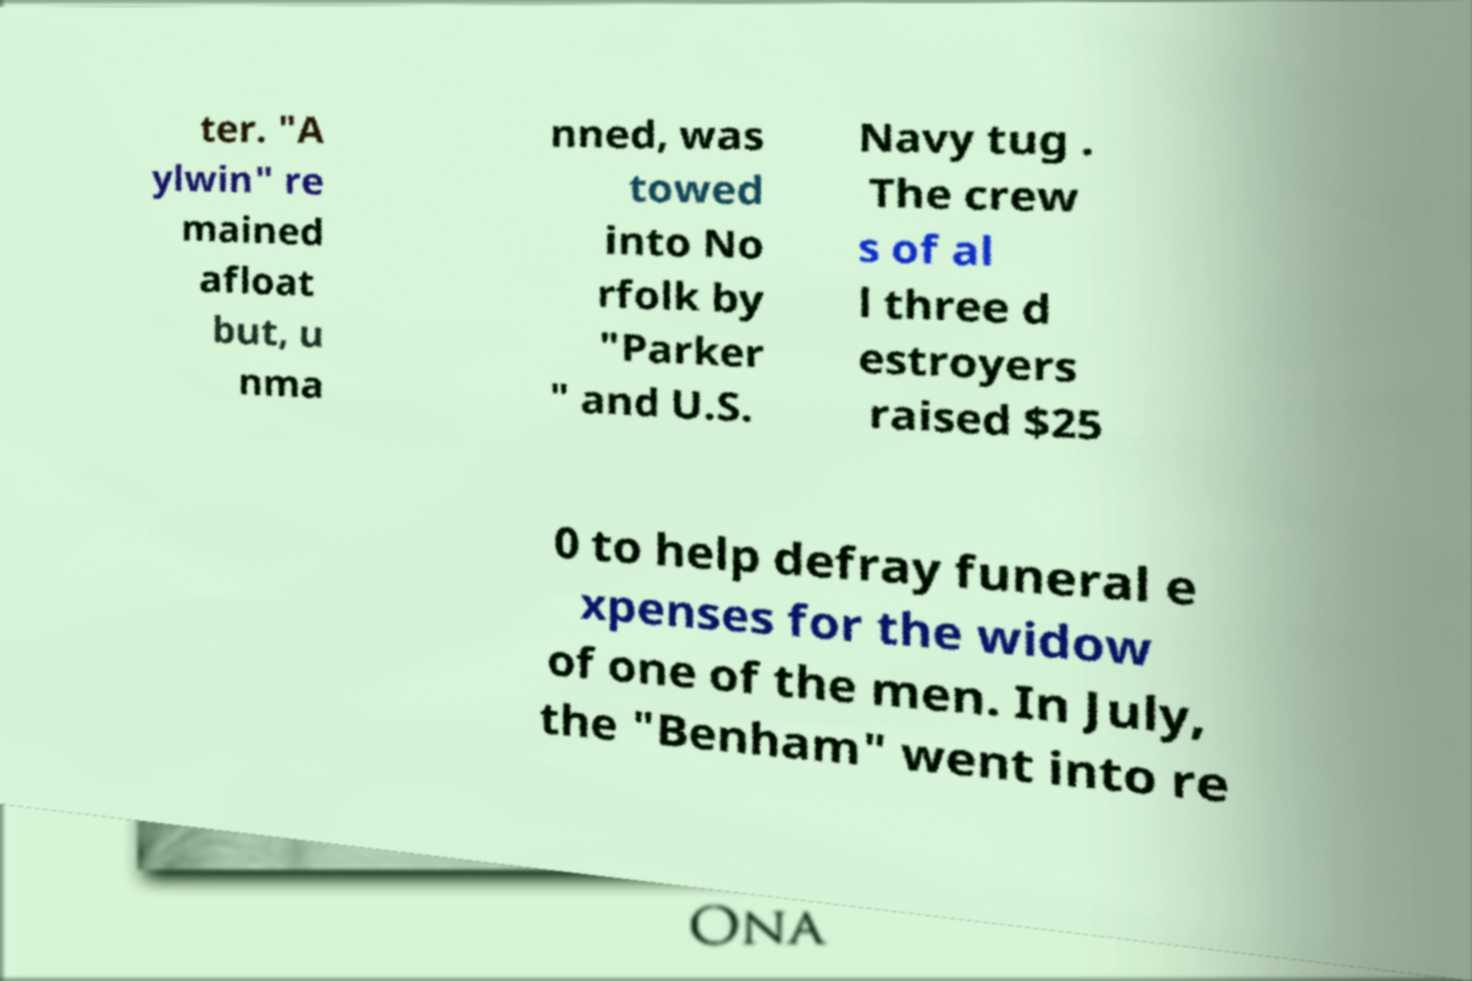Could you extract and type out the text from this image? ter. "A ylwin" re mained afloat but, u nma nned, was towed into No rfolk by "Parker " and U.S. Navy tug . The crew s of al l three d estroyers raised $25 0 to help defray funeral e xpenses for the widow of one of the men. In July, the "Benham" went into re 